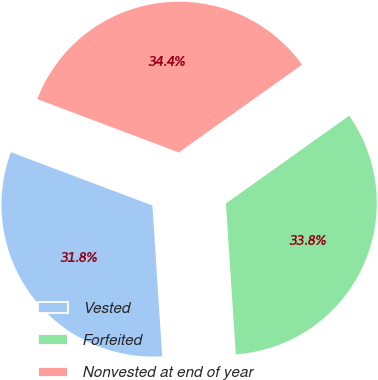Convert chart to OTSL. <chart><loc_0><loc_0><loc_500><loc_500><pie_chart><fcel>Vested<fcel>Forfeited<fcel>Nonvested at end of year<nl><fcel>31.77%<fcel>33.81%<fcel>34.42%<nl></chart> 